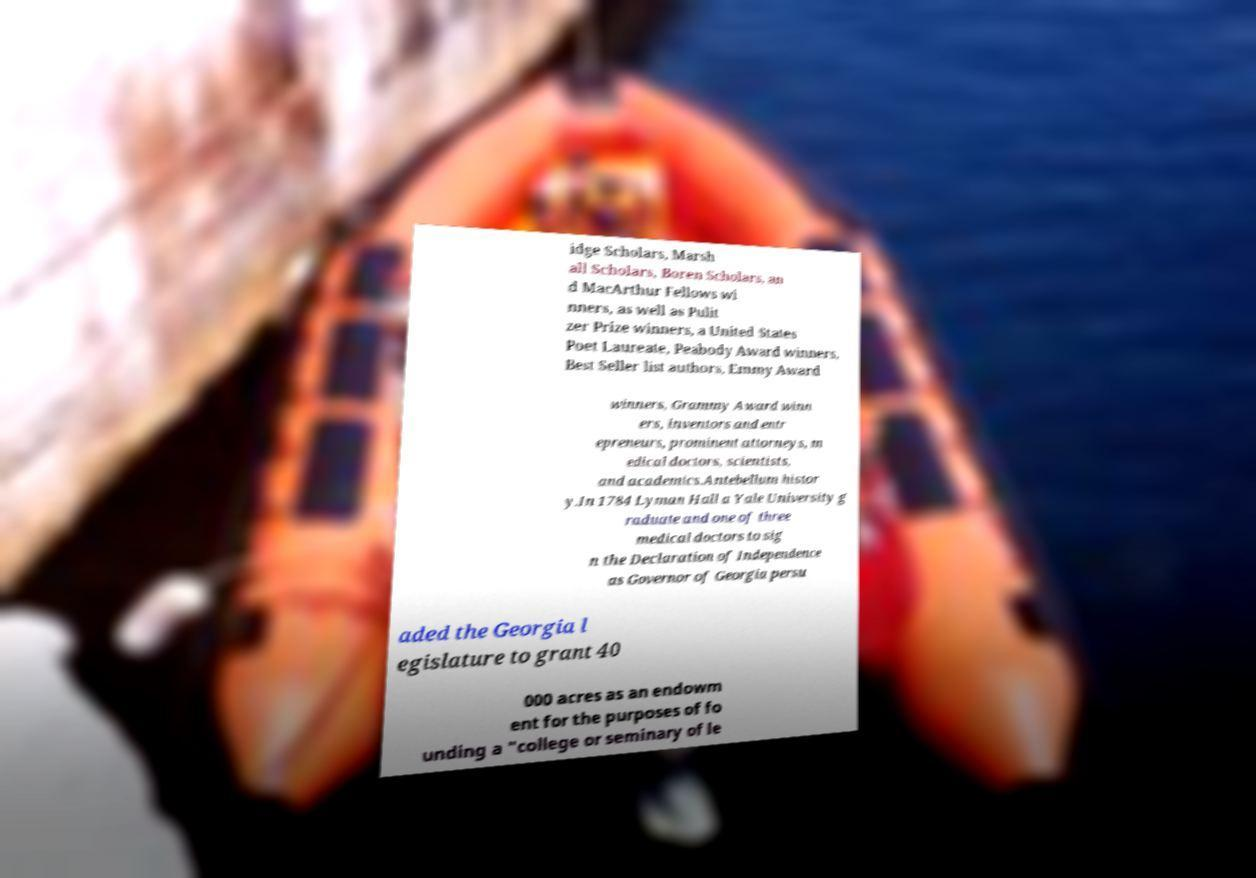Can you read and provide the text displayed in the image?This photo seems to have some interesting text. Can you extract and type it out for me? idge Scholars, Marsh all Scholars, Boren Scholars, an d MacArthur Fellows wi nners, as well as Pulit zer Prize winners, a United States Poet Laureate, Peabody Award winners, Best Seller list authors, Emmy Award winners, Grammy Award winn ers, inventors and entr epreneurs, prominent attorneys, m edical doctors, scientists, and academics.Antebellum histor y.In 1784 Lyman Hall a Yale University g raduate and one of three medical doctors to sig n the Declaration of Independence as Governor of Georgia persu aded the Georgia l egislature to grant 40 000 acres as an endowm ent for the purposes of fo unding a "college or seminary of le 